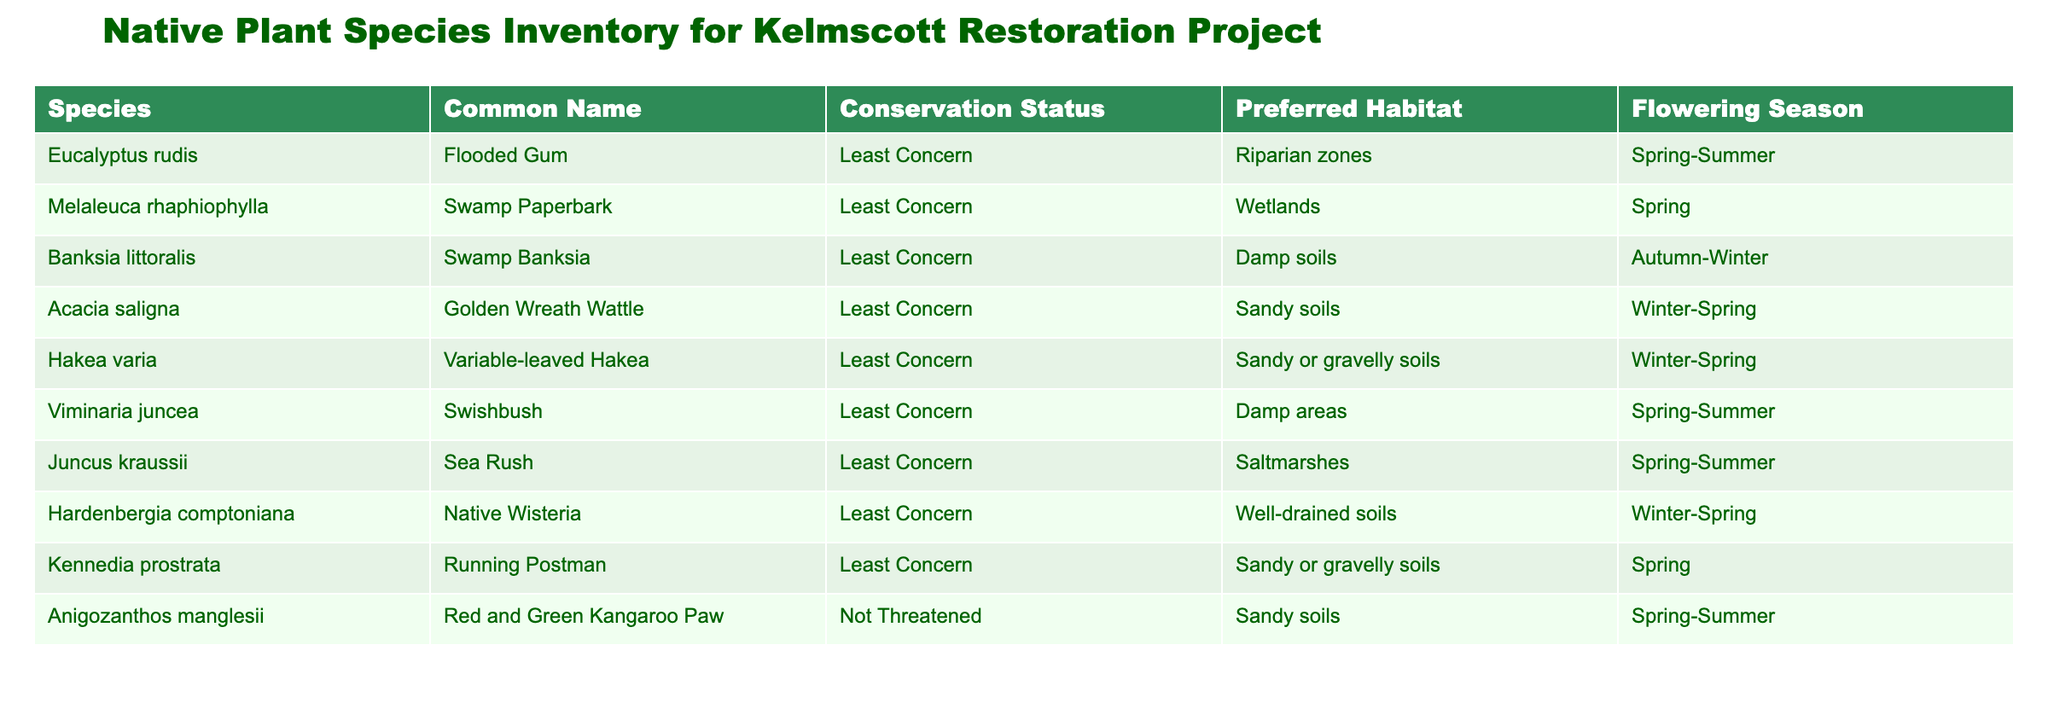What is the common name of Eucalyptus rudis? The table lists the species Eucalyptus rudis and its corresponding common name is "Flooded Gum."
Answer: Flooded Gum Which species is found in wetlands? By examining the "Preferred Habitat" column, I can see that "Melaleuca rhaphiophylla" has "Wetlands" as its habitat.
Answer: Melaleuca rhaphiophylla How many plant species have their preferred habitat in sandy soils? I count the instances of species listed under the "Preferred Habitat" column that mention "Sandy soils." These are "Acacia saligna," "Hakea varia," and "Anigozanthos manglesii," totaling 3 species.
Answer: 3 Do any species have a conservation status of 'Not Threatened'? Looking at the "Conservation Status" column, only "Anigozanthos manglesii" is marked as 'Not Threatened,' which means there is at least one species fitting that criterion.
Answer: Yes Which flowering season occurs most frequently among the listed species? I will analyze the "Flowering Season" column. The seasons mentioned are Spring (5 occurrences), Winter (3 occurrences), and Autumn (1 occurrence). The season occurring most frequently is Spring, with 5 species flowering in that season.
Answer: Spring How does the conservation status of the species in wetland habitats compare to those in sandy or gravelly soils? "Melaleuca rhaphiophylla" (Least Concern) is the only species in wetland habitats. For sandy or gravelly soils, "Acacia saligna," "Hakea varia," and "Kennedia prostrata" are all listed as Least Concern. Both habitats show species with a similar conservation status.
Answer: They are both Least Concern What percentage of the species listed flower in Spring? There are 10 species total, and the count of those that have Spring listed as their flowering season includes "Melaleuca rhaphiophylla," "Viminaria juncea," "Anigozanthos manglesii," among others, which adds up to 5. Calculating the percentage: (5/10) * 100 = 50%.
Answer: 50% Which species has the longest flowering season in terms of summer presence? Examining the "Flowering Season" for hints of summer, "Eucalyptus rudis," "Viminaria juncea," and "Anigozanthos manglesii" all have Spring-Summer. To determine which one has the most extended summer presence, we can conclude that all three extend into summer.
Answer: Eucalyptus rudis, Viminaria juncea, Anigozanthos manglesii 